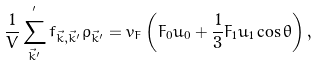<formula> <loc_0><loc_0><loc_500><loc_500>\frac { 1 } { V } \sum ^ { ^ { \prime } } _ { \vec { k } ^ { \prime } } f _ { \vec { k } , \vec { k } ^ { \prime } } \rho _ { \vec { k } ^ { \prime } } = v _ { F } \left ( F _ { 0 } u _ { 0 } + \frac { 1 } { 3 } F _ { 1 } u _ { 1 } \cos \theta \right ) ,</formula> 